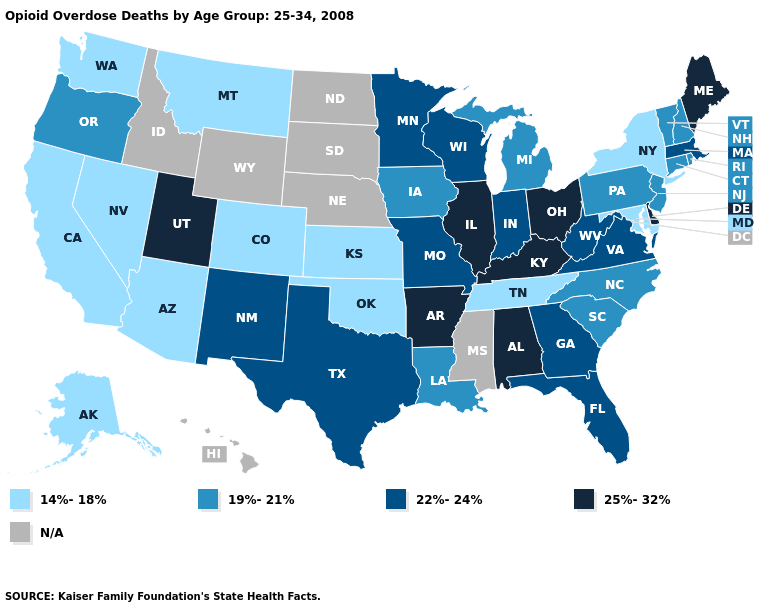Name the states that have a value in the range N/A?
Answer briefly. Hawaii, Idaho, Mississippi, Nebraska, North Dakota, South Dakota, Wyoming. What is the value of New Jersey?
Be succinct. 19%-21%. What is the value of Illinois?
Give a very brief answer. 25%-32%. Name the states that have a value in the range 22%-24%?
Concise answer only. Florida, Georgia, Indiana, Massachusetts, Minnesota, Missouri, New Mexico, Texas, Virginia, West Virginia, Wisconsin. Name the states that have a value in the range 22%-24%?
Keep it brief. Florida, Georgia, Indiana, Massachusetts, Minnesota, Missouri, New Mexico, Texas, Virginia, West Virginia, Wisconsin. Among the states that border Utah , which have the lowest value?
Give a very brief answer. Arizona, Colorado, Nevada. How many symbols are there in the legend?
Answer briefly. 5. Name the states that have a value in the range 22%-24%?
Keep it brief. Florida, Georgia, Indiana, Massachusetts, Minnesota, Missouri, New Mexico, Texas, Virginia, West Virginia, Wisconsin. Does the map have missing data?
Keep it brief. Yes. Among the states that border Arkansas , does Louisiana have the lowest value?
Give a very brief answer. No. Does the map have missing data?
Be succinct. Yes. What is the highest value in the MidWest ?
Quick response, please. 25%-32%. Does New York have the lowest value in the USA?
Concise answer only. Yes. Which states have the highest value in the USA?
Keep it brief. Alabama, Arkansas, Delaware, Illinois, Kentucky, Maine, Ohio, Utah. Name the states that have a value in the range 25%-32%?
Quick response, please. Alabama, Arkansas, Delaware, Illinois, Kentucky, Maine, Ohio, Utah. 